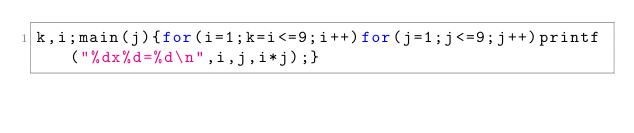Convert code to text. <code><loc_0><loc_0><loc_500><loc_500><_C_>k,i;main(j){for(i=1;k=i<=9;i++)for(j=1;j<=9;j++)printf("%dx%d=%d\n",i,j,i*j);}</code> 